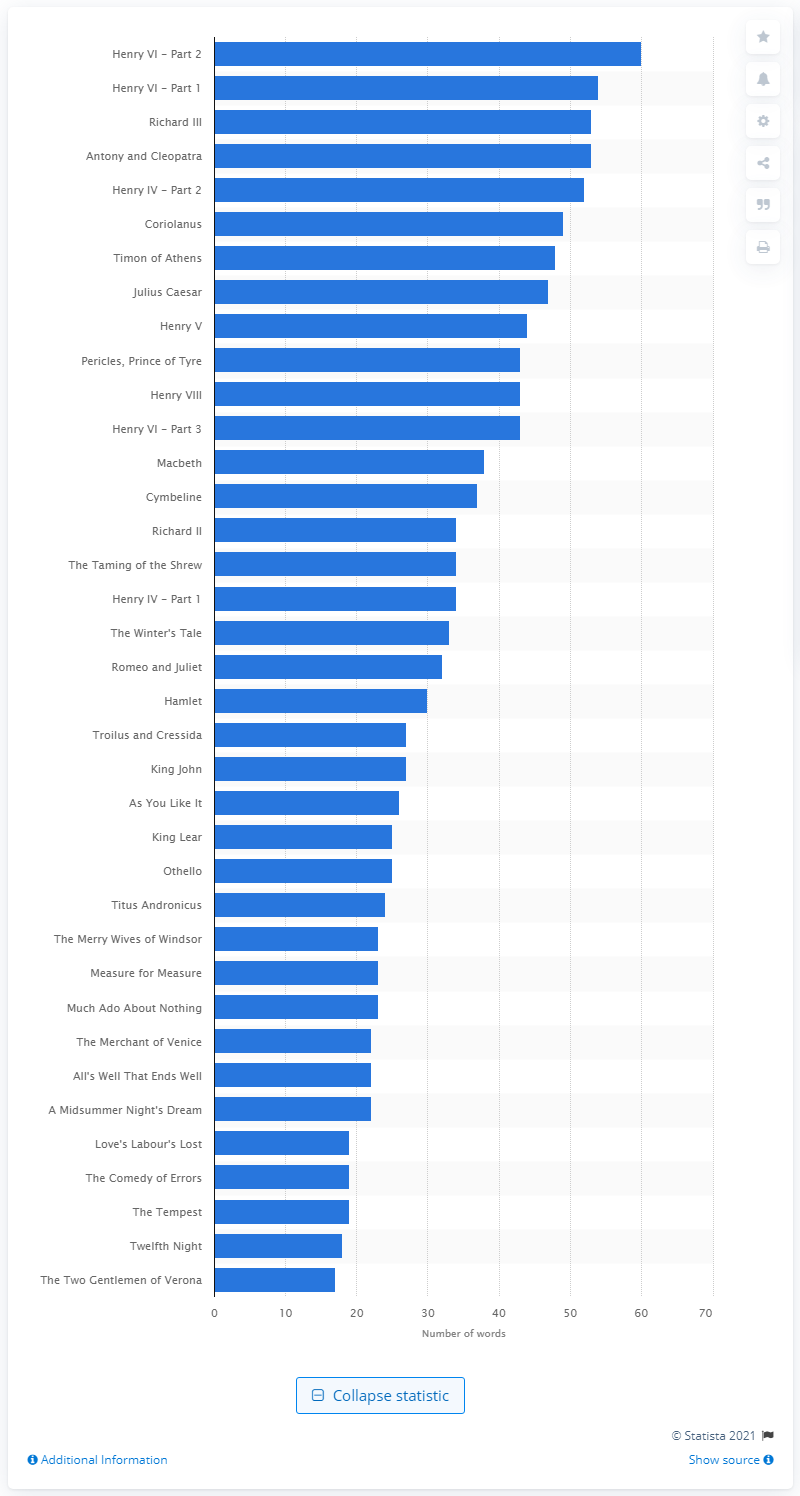Mention a couple of crucial points in this snapshot. The average number of characters per play is 34. 